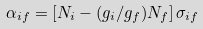Convert formula to latex. <formula><loc_0><loc_0><loc_500><loc_500>\alpha _ { i f } = \left [ N _ { i } - ( g _ { i } / g _ { f } ) N _ { f } \right ] \sigma _ { i f }</formula> 